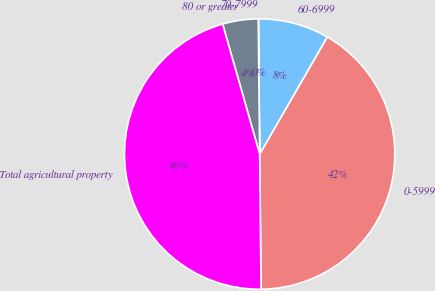Convert chart to OTSL. <chart><loc_0><loc_0><loc_500><loc_500><pie_chart><fcel>0-5999<fcel>60-6999<fcel>70-7999<fcel>80 or greater<fcel>Total agricultural property<nl><fcel>41.51%<fcel>8.48%<fcel>0.02%<fcel>4.25%<fcel>45.75%<nl></chart> 